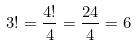<formula> <loc_0><loc_0><loc_500><loc_500>3 ! = \frac { 4 ! } { 4 } = \frac { 2 4 } { 4 } = 6</formula> 